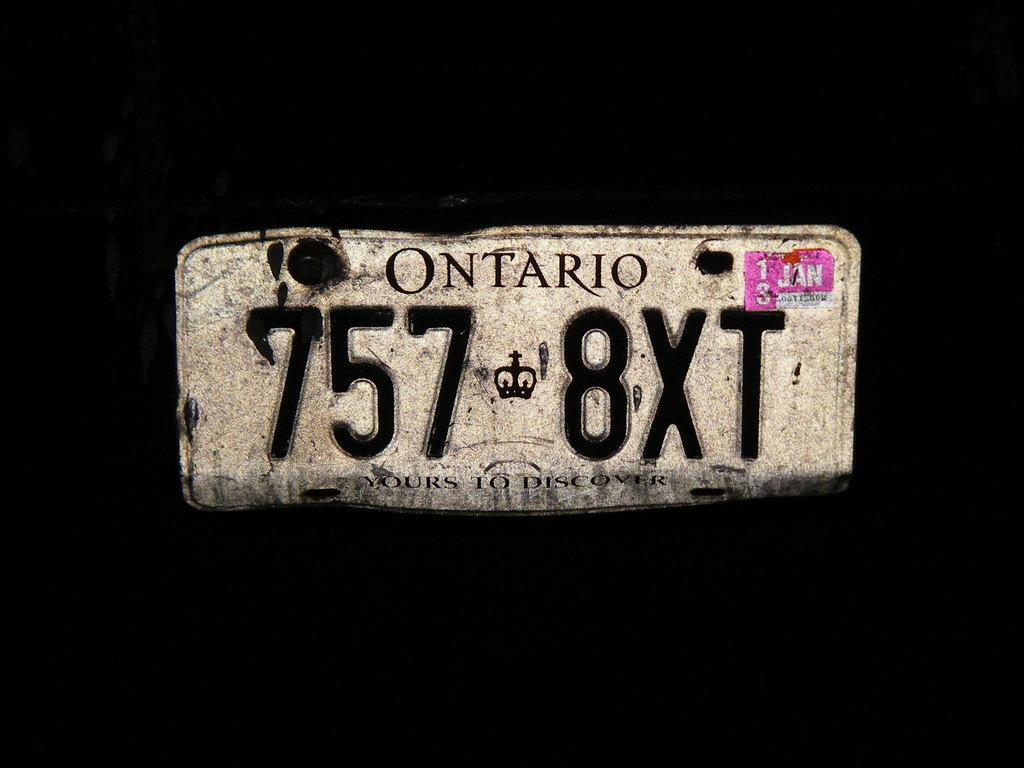What is the main object in the image? There is a board with text in the image. What can be seen in the background of the image? The background of the image is black. What type of wine is being served in the image? There is no wine present in the image; it features a board with text and a black background. How many bags of rice are visible in the image? There are no bags of rice present in the image. 